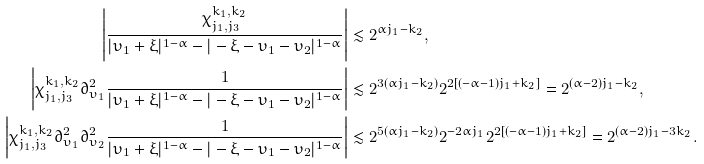Convert formula to latex. <formula><loc_0><loc_0><loc_500><loc_500>\left | \frac { \chi _ { j _ { 1 } , j _ { 3 } } ^ { k _ { 1 } , k _ { 2 } } } { | \upsilon _ { 1 } + \xi | ^ { 1 - \alpha } - | - \xi - \upsilon _ { 1 } - \upsilon _ { 2 } | ^ { 1 - \alpha } } \right | & \lesssim 2 ^ { \alpha j _ { 1 } - k _ { 2 } } , \\ \left | \chi _ { j _ { 1 } , j _ { 3 } } ^ { k _ { 1 } , k _ { 2 } } \partial _ { \upsilon _ { 1 } } ^ { 2 } \frac { 1 } { | \upsilon _ { 1 } + \xi | ^ { 1 - \alpha } - | - \xi - \upsilon _ { 1 } - \upsilon _ { 2 } | ^ { 1 - \alpha } } \right | & \lesssim 2 ^ { 3 ( \alpha j _ { 1 } - k _ { 2 } ) } 2 ^ { 2 [ ( - \alpha - 1 ) j _ { 1 } + k _ { 2 } ] } = 2 ^ { ( \alpha - 2 ) j _ { 1 } - k _ { 2 } } , \\ \left | \chi _ { j _ { 1 } , j _ { 3 } } ^ { k _ { 1 } , k _ { 2 } } \partial _ { \upsilon _ { 1 } } ^ { 2 } \partial _ { \upsilon _ { 2 } } ^ { 2 } \frac { 1 } { | \upsilon _ { 1 } + \xi | ^ { 1 - \alpha } - | - \xi - \upsilon _ { 1 } - \upsilon _ { 2 } | ^ { 1 - \alpha } } \right | & \lesssim 2 ^ { 5 ( \alpha j _ { 1 } - k _ { 2 } ) } 2 ^ { - 2 \alpha j _ { 1 } } 2 ^ { 2 [ ( - \alpha - 1 ) j _ { 1 } + k _ { 2 } ] } = 2 ^ { ( \alpha - 2 ) j _ { 1 } - 3 k _ { 2 } } .</formula> 